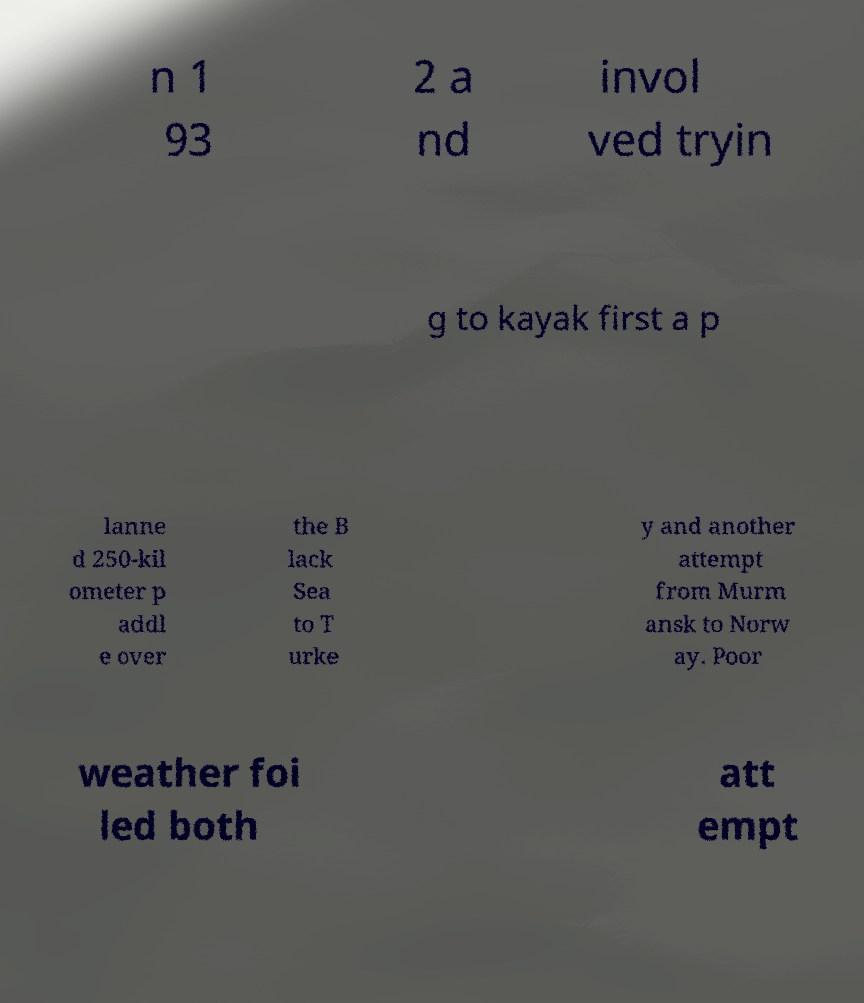What messages or text are displayed in this image? I need them in a readable, typed format. n 1 93 2 a nd invol ved tryin g to kayak first a p lanne d 250-kil ometer p addl e over the B lack Sea to T urke y and another attempt from Murm ansk to Norw ay. Poor weather foi led both att empt 